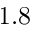<formula> <loc_0><loc_0><loc_500><loc_500>1 . 8</formula> 